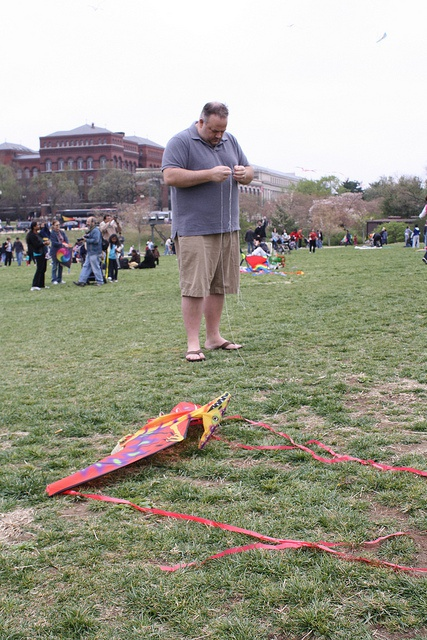Describe the objects in this image and their specific colors. I can see people in white, gray, and darkgray tones, kite in white, lightpink, salmon, and gray tones, people in white, gray, black, and darkgray tones, people in white, gray, darkblue, and darkgray tones, and people in white, navy, gray, black, and darkblue tones in this image. 